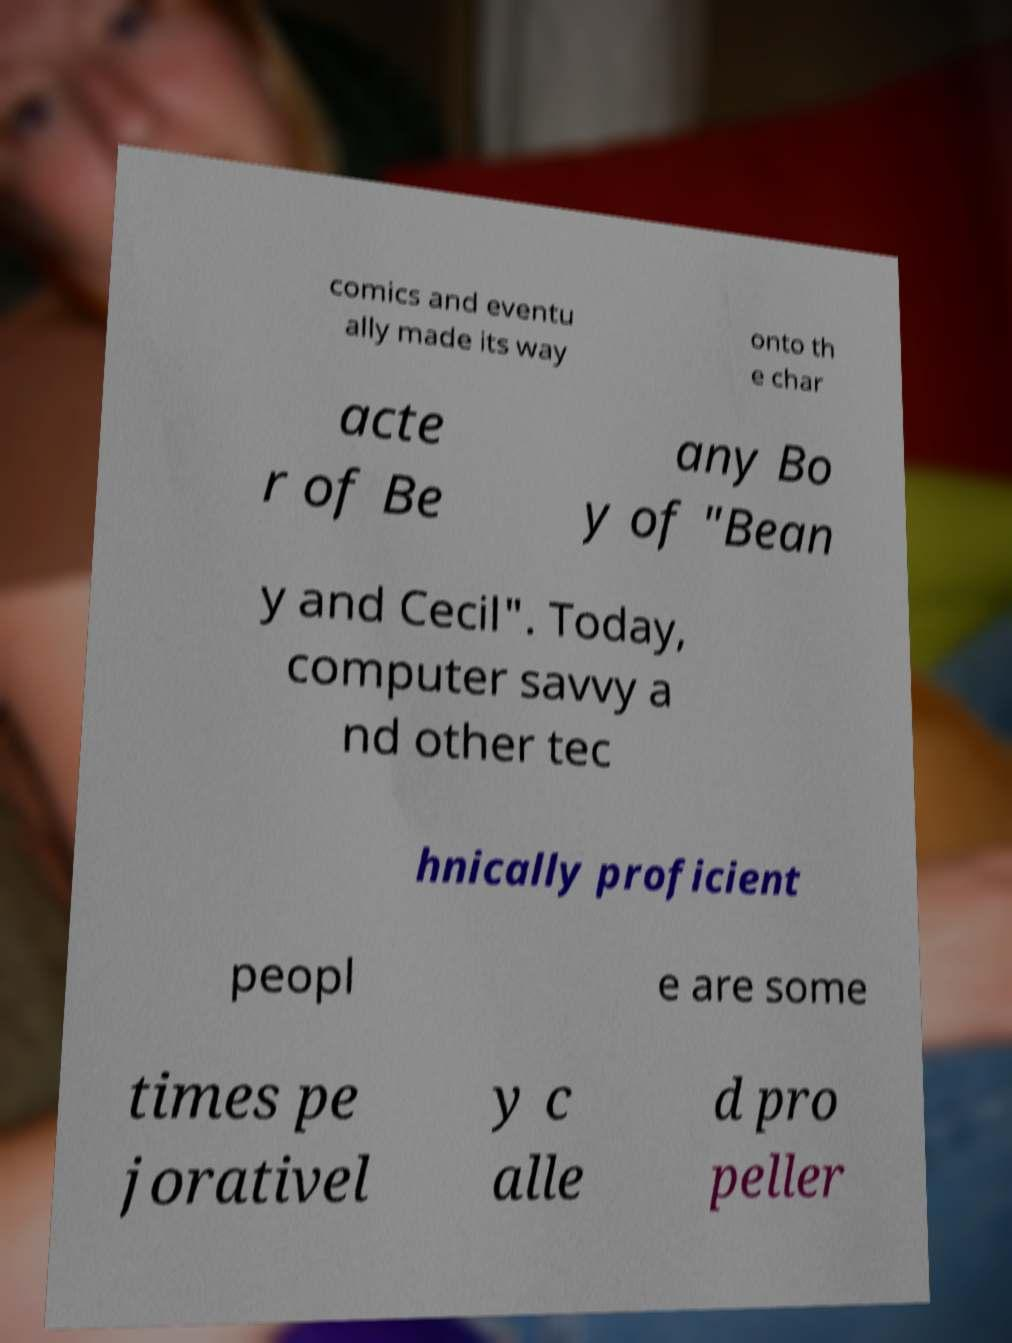There's text embedded in this image that I need extracted. Can you transcribe it verbatim? comics and eventu ally made its way onto th e char acte r of Be any Bo y of "Bean y and Cecil". Today, computer savvy a nd other tec hnically proficient peopl e are some times pe jorativel y c alle d pro peller 